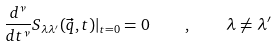<formula> <loc_0><loc_0><loc_500><loc_500>\frac { d ^ { \nu } } { d t ^ { \nu } } S _ { \lambda \lambda ^ { \prime } } ( \vec { q } , t ) | _ { t = 0 } = 0 \quad , \quad \lambda \neq \lambda ^ { \prime }</formula> 